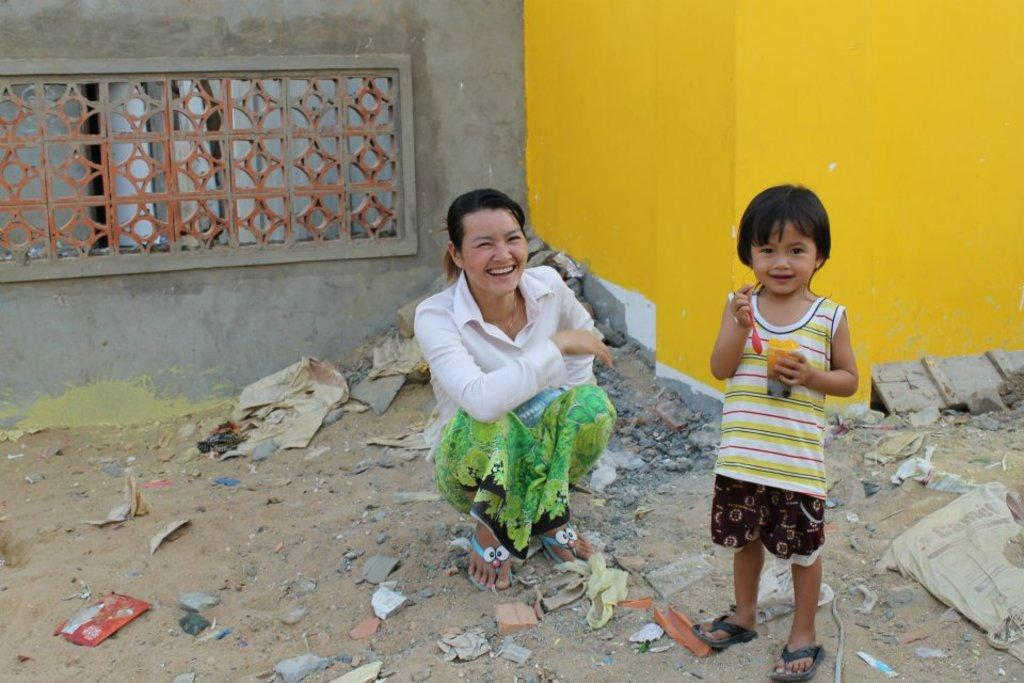What is the kid in the image doing? The kid is standing and holding a spoon and a glass. What can be seen in the kid's hands? The kid is holding a spoon and a glass. What is the position of the other person in the image? The other person is in a squat position. What is visible in the background of the image? There is a building in the background of the image. What type of truck can be seen driving by in the image? There is no truck present in the image. How many crows are sitting on the building in the background? There are no crows visible in the image; only the building is present in the background. 